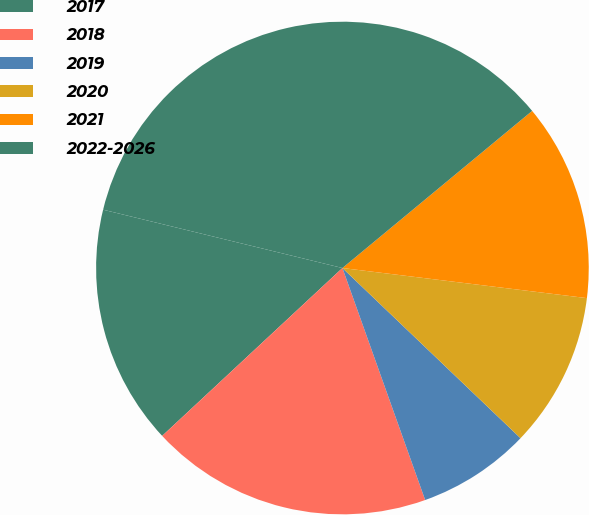Convert chart to OTSL. <chart><loc_0><loc_0><loc_500><loc_500><pie_chart><fcel>2017<fcel>2018<fcel>2019<fcel>2020<fcel>2021<fcel>2022-2026<nl><fcel>15.74%<fcel>18.52%<fcel>7.41%<fcel>10.19%<fcel>12.96%<fcel>35.19%<nl></chart> 